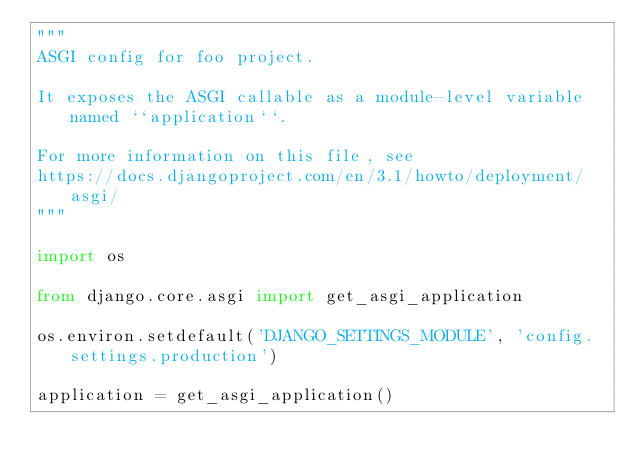<code> <loc_0><loc_0><loc_500><loc_500><_Python_>"""
ASGI config for foo project.

It exposes the ASGI callable as a module-level variable named ``application``.

For more information on this file, see
https://docs.djangoproject.com/en/3.1/howto/deployment/asgi/
"""

import os

from django.core.asgi import get_asgi_application

os.environ.setdefault('DJANGO_SETTINGS_MODULE', 'config.settings.production')

application = get_asgi_application()
</code> 